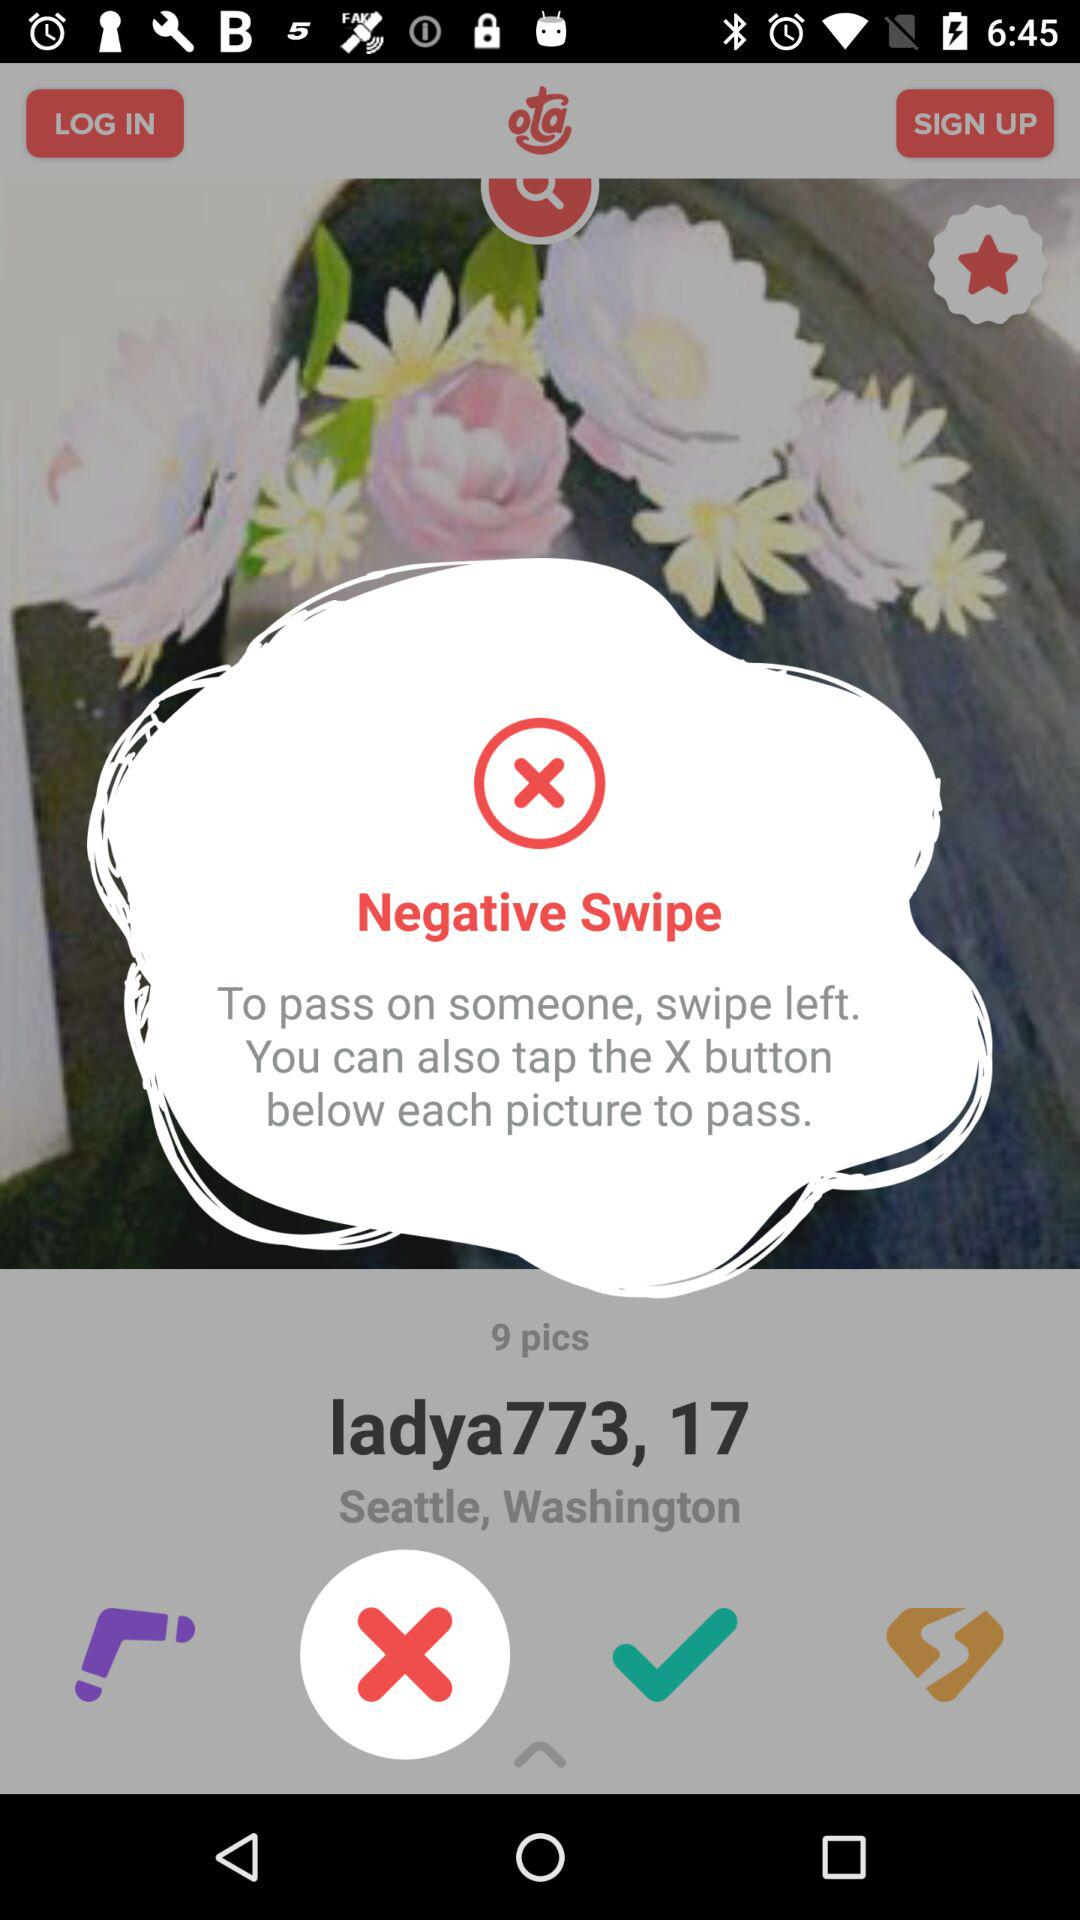What is the user name? The user name is ladya773. 